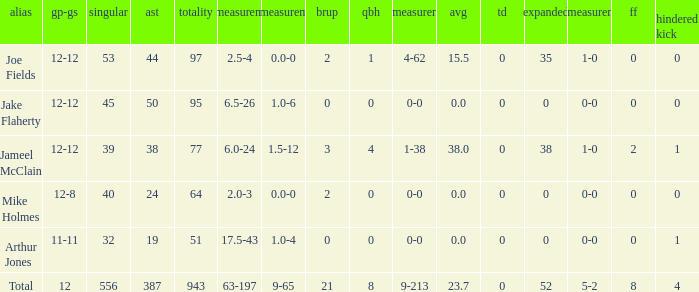What is the total brup for the team? 21.0. 